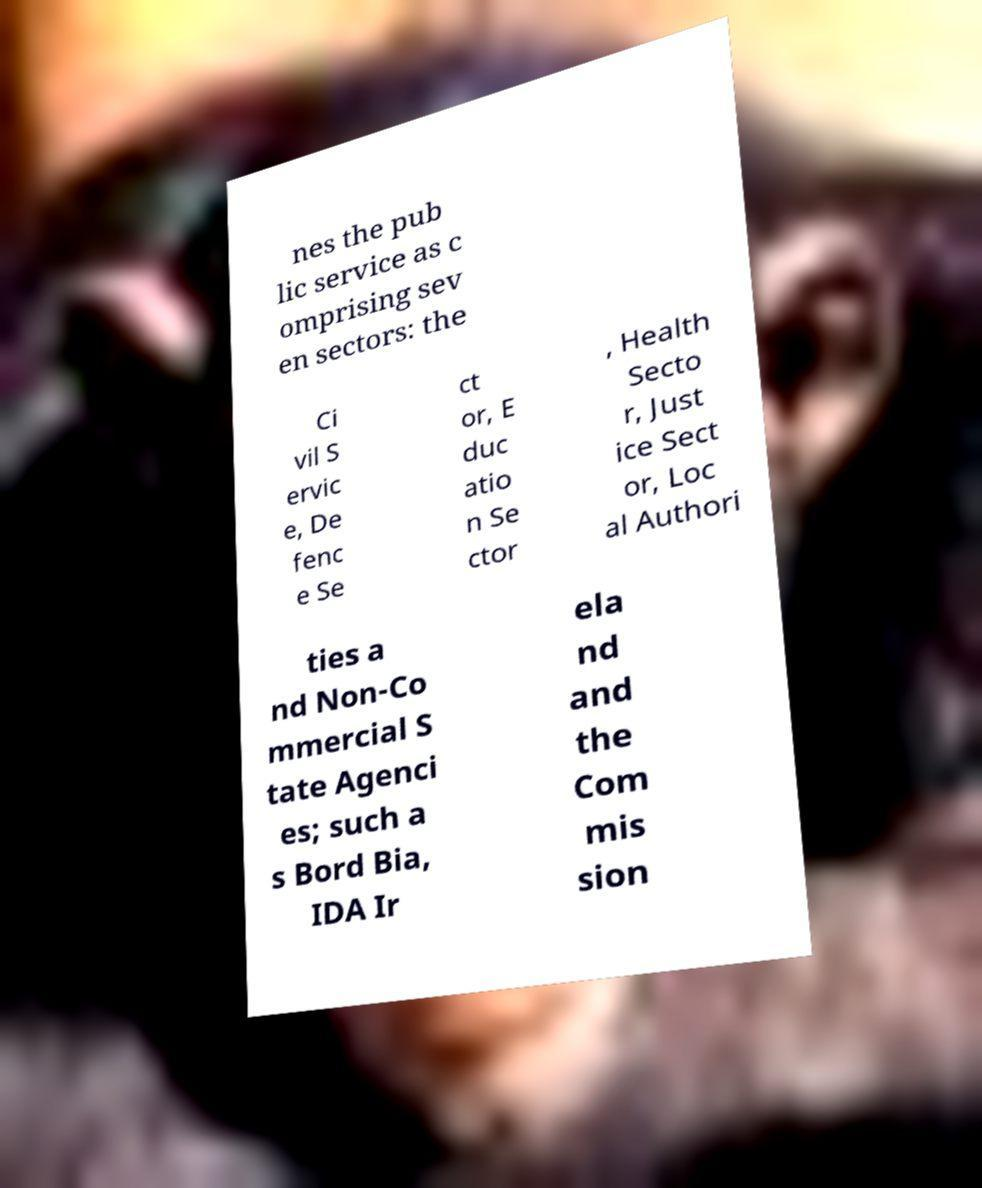Can you accurately transcribe the text from the provided image for me? nes the pub lic service as c omprising sev en sectors: the Ci vil S ervic e, De fenc e Se ct or, E duc atio n Se ctor , Health Secto r, Just ice Sect or, Loc al Authori ties a nd Non-Co mmercial S tate Agenci es; such a s Bord Bia, IDA Ir ela nd and the Com mis sion 